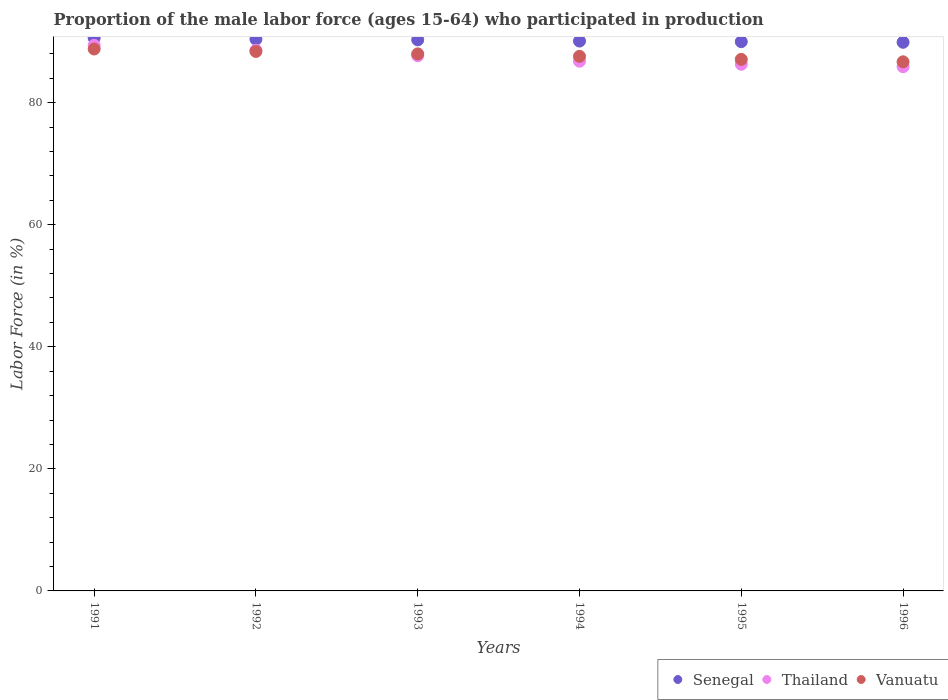How many different coloured dotlines are there?
Make the answer very short. 3. What is the proportion of the male labor force who participated in production in Vanuatu in 1992?
Keep it short and to the point. 88.4. Across all years, what is the maximum proportion of the male labor force who participated in production in Thailand?
Provide a short and direct response. 89.4. Across all years, what is the minimum proportion of the male labor force who participated in production in Thailand?
Your answer should be compact. 85.9. In which year was the proportion of the male labor force who participated in production in Senegal minimum?
Make the answer very short. 1996. What is the total proportion of the male labor force who participated in production in Thailand in the graph?
Your answer should be very brief. 524.7. What is the difference between the proportion of the male labor force who participated in production in Vanuatu in 1992 and that in 1993?
Offer a very short reply. 0.4. What is the difference between the proportion of the male labor force who participated in production in Thailand in 1994 and the proportion of the male labor force who participated in production in Senegal in 1996?
Make the answer very short. -3.1. What is the average proportion of the male labor force who participated in production in Senegal per year?
Provide a short and direct response. 90.22. In the year 1991, what is the difference between the proportion of the male labor force who participated in production in Senegal and proportion of the male labor force who participated in production in Thailand?
Give a very brief answer. 1.2. In how many years, is the proportion of the male labor force who participated in production in Vanuatu greater than 80 %?
Ensure brevity in your answer.  6. What is the ratio of the proportion of the male labor force who participated in production in Thailand in 1991 to that in 1995?
Provide a short and direct response. 1.04. Is the proportion of the male labor force who participated in production in Vanuatu in 1992 less than that in 1993?
Ensure brevity in your answer.  No. What is the difference between the highest and the second highest proportion of the male labor force who participated in production in Vanuatu?
Give a very brief answer. 0.4. What is the difference between the highest and the lowest proportion of the male labor force who participated in production in Thailand?
Make the answer very short. 3.5. In how many years, is the proportion of the male labor force who participated in production in Senegal greater than the average proportion of the male labor force who participated in production in Senegal taken over all years?
Make the answer very short. 3. Is the sum of the proportion of the male labor force who participated in production in Thailand in 1991 and 1996 greater than the maximum proportion of the male labor force who participated in production in Senegal across all years?
Offer a terse response. Yes. Is it the case that in every year, the sum of the proportion of the male labor force who participated in production in Vanuatu and proportion of the male labor force who participated in production in Thailand  is greater than the proportion of the male labor force who participated in production in Senegal?
Provide a short and direct response. Yes. Is the proportion of the male labor force who participated in production in Senegal strictly less than the proportion of the male labor force who participated in production in Vanuatu over the years?
Your answer should be very brief. No. Are the values on the major ticks of Y-axis written in scientific E-notation?
Your response must be concise. No. Does the graph contain any zero values?
Provide a succinct answer. No. Where does the legend appear in the graph?
Ensure brevity in your answer.  Bottom right. What is the title of the graph?
Provide a short and direct response. Proportion of the male labor force (ages 15-64) who participated in production. What is the label or title of the Y-axis?
Your answer should be compact. Labor Force (in %). What is the Labor Force (in %) of Senegal in 1991?
Your answer should be very brief. 90.6. What is the Labor Force (in %) in Thailand in 1991?
Your answer should be very brief. 89.4. What is the Labor Force (in %) in Vanuatu in 1991?
Offer a very short reply. 88.8. What is the Labor Force (in %) of Senegal in 1992?
Offer a very short reply. 90.4. What is the Labor Force (in %) of Thailand in 1992?
Your answer should be very brief. 88.6. What is the Labor Force (in %) in Vanuatu in 1992?
Your answer should be compact. 88.4. What is the Labor Force (in %) in Senegal in 1993?
Keep it short and to the point. 90.3. What is the Labor Force (in %) of Thailand in 1993?
Keep it short and to the point. 87.7. What is the Labor Force (in %) in Vanuatu in 1993?
Offer a terse response. 88. What is the Labor Force (in %) of Senegal in 1994?
Offer a very short reply. 90.1. What is the Labor Force (in %) in Thailand in 1994?
Your answer should be very brief. 86.8. What is the Labor Force (in %) in Vanuatu in 1994?
Give a very brief answer. 87.6. What is the Labor Force (in %) in Thailand in 1995?
Your answer should be compact. 86.3. What is the Labor Force (in %) in Vanuatu in 1995?
Your response must be concise. 87.1. What is the Labor Force (in %) of Senegal in 1996?
Offer a very short reply. 89.9. What is the Labor Force (in %) of Thailand in 1996?
Your answer should be very brief. 85.9. What is the Labor Force (in %) of Vanuatu in 1996?
Make the answer very short. 86.7. Across all years, what is the maximum Labor Force (in %) of Senegal?
Give a very brief answer. 90.6. Across all years, what is the maximum Labor Force (in %) in Thailand?
Provide a short and direct response. 89.4. Across all years, what is the maximum Labor Force (in %) of Vanuatu?
Your answer should be very brief. 88.8. Across all years, what is the minimum Labor Force (in %) in Senegal?
Your response must be concise. 89.9. Across all years, what is the minimum Labor Force (in %) of Thailand?
Ensure brevity in your answer.  85.9. Across all years, what is the minimum Labor Force (in %) of Vanuatu?
Provide a succinct answer. 86.7. What is the total Labor Force (in %) of Senegal in the graph?
Your answer should be very brief. 541.3. What is the total Labor Force (in %) of Thailand in the graph?
Ensure brevity in your answer.  524.7. What is the total Labor Force (in %) of Vanuatu in the graph?
Your answer should be very brief. 526.6. What is the difference between the Labor Force (in %) of Senegal in 1991 and that in 1992?
Your response must be concise. 0.2. What is the difference between the Labor Force (in %) in Thailand in 1991 and that in 1992?
Your response must be concise. 0.8. What is the difference between the Labor Force (in %) of Vanuatu in 1991 and that in 1992?
Your response must be concise. 0.4. What is the difference between the Labor Force (in %) of Vanuatu in 1991 and that in 1993?
Your answer should be very brief. 0.8. What is the difference between the Labor Force (in %) of Senegal in 1991 and that in 1994?
Offer a very short reply. 0.5. What is the difference between the Labor Force (in %) of Thailand in 1991 and that in 1995?
Your answer should be very brief. 3.1. What is the difference between the Labor Force (in %) of Vanuatu in 1991 and that in 1996?
Provide a short and direct response. 2.1. What is the difference between the Labor Force (in %) of Senegal in 1992 and that in 1994?
Give a very brief answer. 0.3. What is the difference between the Labor Force (in %) of Thailand in 1992 and that in 1995?
Keep it short and to the point. 2.3. What is the difference between the Labor Force (in %) in Vanuatu in 1992 and that in 1995?
Keep it short and to the point. 1.3. What is the difference between the Labor Force (in %) of Thailand in 1992 and that in 1996?
Provide a succinct answer. 2.7. What is the difference between the Labor Force (in %) of Thailand in 1993 and that in 1994?
Offer a very short reply. 0.9. What is the difference between the Labor Force (in %) of Thailand in 1993 and that in 1995?
Give a very brief answer. 1.4. What is the difference between the Labor Force (in %) in Thailand in 1993 and that in 1996?
Offer a very short reply. 1.8. What is the difference between the Labor Force (in %) in Vanuatu in 1993 and that in 1996?
Make the answer very short. 1.3. What is the difference between the Labor Force (in %) of Thailand in 1994 and that in 1995?
Offer a terse response. 0.5. What is the difference between the Labor Force (in %) of Vanuatu in 1994 and that in 1996?
Your answer should be compact. 0.9. What is the difference between the Labor Force (in %) in Senegal in 1991 and the Labor Force (in %) in Vanuatu in 1992?
Give a very brief answer. 2.2. What is the difference between the Labor Force (in %) of Senegal in 1991 and the Labor Force (in %) of Thailand in 1993?
Offer a very short reply. 2.9. What is the difference between the Labor Force (in %) of Senegal in 1991 and the Labor Force (in %) of Vanuatu in 1993?
Your answer should be compact. 2.6. What is the difference between the Labor Force (in %) of Thailand in 1991 and the Labor Force (in %) of Vanuatu in 1993?
Your response must be concise. 1.4. What is the difference between the Labor Force (in %) in Senegal in 1991 and the Labor Force (in %) in Thailand in 1994?
Your response must be concise. 3.8. What is the difference between the Labor Force (in %) of Senegal in 1991 and the Labor Force (in %) of Vanuatu in 1994?
Your answer should be compact. 3. What is the difference between the Labor Force (in %) of Senegal in 1991 and the Labor Force (in %) of Vanuatu in 1995?
Give a very brief answer. 3.5. What is the difference between the Labor Force (in %) of Thailand in 1991 and the Labor Force (in %) of Vanuatu in 1995?
Ensure brevity in your answer.  2.3. What is the difference between the Labor Force (in %) in Senegal in 1991 and the Labor Force (in %) in Vanuatu in 1996?
Offer a very short reply. 3.9. What is the difference between the Labor Force (in %) in Senegal in 1992 and the Labor Force (in %) in Thailand in 1993?
Offer a terse response. 2.7. What is the difference between the Labor Force (in %) of Senegal in 1992 and the Labor Force (in %) of Vanuatu in 1993?
Keep it short and to the point. 2.4. What is the difference between the Labor Force (in %) in Thailand in 1992 and the Labor Force (in %) in Vanuatu in 1993?
Provide a succinct answer. 0.6. What is the difference between the Labor Force (in %) of Senegal in 1992 and the Labor Force (in %) of Vanuatu in 1995?
Keep it short and to the point. 3.3. What is the difference between the Labor Force (in %) of Thailand in 1992 and the Labor Force (in %) of Vanuatu in 1995?
Your answer should be compact. 1.5. What is the difference between the Labor Force (in %) in Senegal in 1992 and the Labor Force (in %) in Thailand in 1996?
Offer a terse response. 4.5. What is the difference between the Labor Force (in %) of Senegal in 1992 and the Labor Force (in %) of Vanuatu in 1996?
Your response must be concise. 3.7. What is the difference between the Labor Force (in %) in Thailand in 1992 and the Labor Force (in %) in Vanuatu in 1996?
Give a very brief answer. 1.9. What is the difference between the Labor Force (in %) in Senegal in 1993 and the Labor Force (in %) in Vanuatu in 1994?
Make the answer very short. 2.7. What is the difference between the Labor Force (in %) of Senegal in 1993 and the Labor Force (in %) of Thailand in 1995?
Offer a terse response. 4. What is the difference between the Labor Force (in %) of Senegal in 1993 and the Labor Force (in %) of Vanuatu in 1995?
Give a very brief answer. 3.2. What is the difference between the Labor Force (in %) of Thailand in 1993 and the Labor Force (in %) of Vanuatu in 1995?
Your answer should be compact. 0.6. What is the difference between the Labor Force (in %) of Senegal in 1993 and the Labor Force (in %) of Vanuatu in 1996?
Provide a short and direct response. 3.6. What is the difference between the Labor Force (in %) in Senegal in 1994 and the Labor Force (in %) in Thailand in 1995?
Make the answer very short. 3.8. What is the difference between the Labor Force (in %) in Thailand in 1994 and the Labor Force (in %) in Vanuatu in 1995?
Provide a short and direct response. -0.3. What is the difference between the Labor Force (in %) in Senegal in 1994 and the Labor Force (in %) in Vanuatu in 1996?
Ensure brevity in your answer.  3.4. What is the difference between the Labor Force (in %) of Thailand in 1994 and the Labor Force (in %) of Vanuatu in 1996?
Provide a short and direct response. 0.1. What is the difference between the Labor Force (in %) of Thailand in 1995 and the Labor Force (in %) of Vanuatu in 1996?
Provide a short and direct response. -0.4. What is the average Labor Force (in %) of Senegal per year?
Give a very brief answer. 90.22. What is the average Labor Force (in %) in Thailand per year?
Make the answer very short. 87.45. What is the average Labor Force (in %) in Vanuatu per year?
Provide a short and direct response. 87.77. In the year 1991, what is the difference between the Labor Force (in %) of Thailand and Labor Force (in %) of Vanuatu?
Make the answer very short. 0.6. In the year 1992, what is the difference between the Labor Force (in %) in Senegal and Labor Force (in %) in Vanuatu?
Provide a short and direct response. 2. In the year 1993, what is the difference between the Labor Force (in %) in Senegal and Labor Force (in %) in Thailand?
Your response must be concise. 2.6. In the year 1993, what is the difference between the Labor Force (in %) in Senegal and Labor Force (in %) in Vanuatu?
Keep it short and to the point. 2.3. In the year 1994, what is the difference between the Labor Force (in %) of Senegal and Labor Force (in %) of Thailand?
Provide a short and direct response. 3.3. In the year 1995, what is the difference between the Labor Force (in %) in Senegal and Labor Force (in %) in Thailand?
Your response must be concise. 3.7. In the year 1995, what is the difference between the Labor Force (in %) of Thailand and Labor Force (in %) of Vanuatu?
Ensure brevity in your answer.  -0.8. In the year 1996, what is the difference between the Labor Force (in %) of Senegal and Labor Force (in %) of Thailand?
Provide a short and direct response. 4. In the year 1996, what is the difference between the Labor Force (in %) of Thailand and Labor Force (in %) of Vanuatu?
Provide a succinct answer. -0.8. What is the ratio of the Labor Force (in %) of Thailand in 1991 to that in 1992?
Your response must be concise. 1.01. What is the ratio of the Labor Force (in %) in Vanuatu in 1991 to that in 1992?
Provide a short and direct response. 1. What is the ratio of the Labor Force (in %) of Senegal in 1991 to that in 1993?
Your response must be concise. 1. What is the ratio of the Labor Force (in %) of Thailand in 1991 to that in 1993?
Your answer should be very brief. 1.02. What is the ratio of the Labor Force (in %) in Vanuatu in 1991 to that in 1993?
Keep it short and to the point. 1.01. What is the ratio of the Labor Force (in %) in Senegal in 1991 to that in 1994?
Provide a succinct answer. 1.01. What is the ratio of the Labor Force (in %) of Vanuatu in 1991 to that in 1994?
Give a very brief answer. 1.01. What is the ratio of the Labor Force (in %) in Thailand in 1991 to that in 1995?
Your answer should be compact. 1.04. What is the ratio of the Labor Force (in %) of Vanuatu in 1991 to that in 1995?
Give a very brief answer. 1.02. What is the ratio of the Labor Force (in %) of Senegal in 1991 to that in 1996?
Your answer should be compact. 1.01. What is the ratio of the Labor Force (in %) of Thailand in 1991 to that in 1996?
Offer a terse response. 1.04. What is the ratio of the Labor Force (in %) in Vanuatu in 1991 to that in 1996?
Provide a succinct answer. 1.02. What is the ratio of the Labor Force (in %) in Senegal in 1992 to that in 1993?
Provide a short and direct response. 1. What is the ratio of the Labor Force (in %) of Thailand in 1992 to that in 1993?
Make the answer very short. 1.01. What is the ratio of the Labor Force (in %) in Senegal in 1992 to that in 1994?
Offer a terse response. 1. What is the ratio of the Labor Force (in %) in Thailand in 1992 to that in 1994?
Your answer should be compact. 1.02. What is the ratio of the Labor Force (in %) in Vanuatu in 1992 to that in 1994?
Offer a very short reply. 1.01. What is the ratio of the Labor Force (in %) in Thailand in 1992 to that in 1995?
Keep it short and to the point. 1.03. What is the ratio of the Labor Force (in %) in Vanuatu in 1992 to that in 1995?
Your answer should be very brief. 1.01. What is the ratio of the Labor Force (in %) of Senegal in 1992 to that in 1996?
Keep it short and to the point. 1.01. What is the ratio of the Labor Force (in %) in Thailand in 1992 to that in 1996?
Give a very brief answer. 1.03. What is the ratio of the Labor Force (in %) of Vanuatu in 1992 to that in 1996?
Your answer should be very brief. 1.02. What is the ratio of the Labor Force (in %) in Thailand in 1993 to that in 1994?
Ensure brevity in your answer.  1.01. What is the ratio of the Labor Force (in %) of Vanuatu in 1993 to that in 1994?
Provide a succinct answer. 1. What is the ratio of the Labor Force (in %) of Thailand in 1993 to that in 1995?
Ensure brevity in your answer.  1.02. What is the ratio of the Labor Force (in %) in Vanuatu in 1993 to that in 1995?
Offer a very short reply. 1.01. What is the ratio of the Labor Force (in %) of Vanuatu in 1993 to that in 1996?
Make the answer very short. 1.01. What is the ratio of the Labor Force (in %) in Thailand in 1994 to that in 1995?
Your response must be concise. 1.01. What is the ratio of the Labor Force (in %) of Thailand in 1994 to that in 1996?
Keep it short and to the point. 1.01. What is the ratio of the Labor Force (in %) of Vanuatu in 1994 to that in 1996?
Give a very brief answer. 1.01. What is the ratio of the Labor Force (in %) of Senegal in 1995 to that in 1996?
Offer a very short reply. 1. What is the ratio of the Labor Force (in %) of Thailand in 1995 to that in 1996?
Offer a terse response. 1. What is the difference between the highest and the second highest Labor Force (in %) in Senegal?
Provide a succinct answer. 0.2. What is the difference between the highest and the second highest Labor Force (in %) in Vanuatu?
Give a very brief answer. 0.4. What is the difference between the highest and the lowest Labor Force (in %) of Senegal?
Offer a very short reply. 0.7. What is the difference between the highest and the lowest Labor Force (in %) in Thailand?
Offer a very short reply. 3.5. 